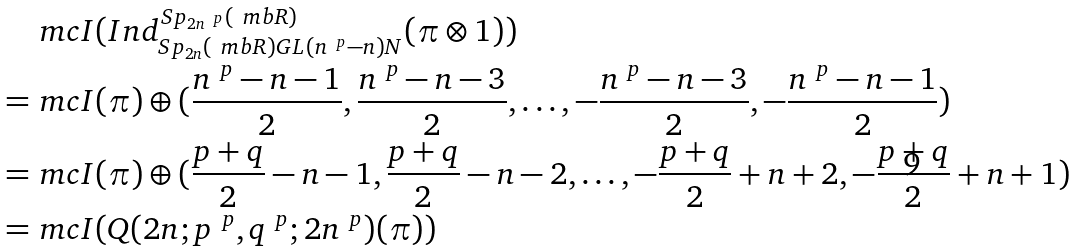<formula> <loc_0><loc_0><loc_500><loc_500>& \ m c I ( I n d _ { S p _ { 2 n } ( \ m b R ) G L ( n ^ { \ p } - n ) N } ^ { S p _ { 2 n ^ { \ p } } ( \ m b R ) } ( \pi \otimes 1 ) ) \\ = & \ m c I ( \pi ) \oplus ( \frac { n ^ { \ p } - n - 1 } { 2 } , \frac { n ^ { \ p } - n - 3 } { 2 } , \dots , - \frac { n ^ { \ p } - n - 3 } { 2 } , - \frac { n ^ { \ p } - n - 1 } { 2 } ) \\ = & \ m c I ( \pi ) \oplus ( \frac { p + q } { 2 } - n - 1 , \frac { p + q } { 2 } - n - 2 , \dots , - \frac { p + q } { 2 } + n + 2 , - \frac { p + q } { 2 } + n + 1 ) \\ = & \ m c I ( Q ( 2 n ; p ^ { \ p } , q ^ { \ p } ; 2 n ^ { \ p } ) ( \pi ) )</formula> 